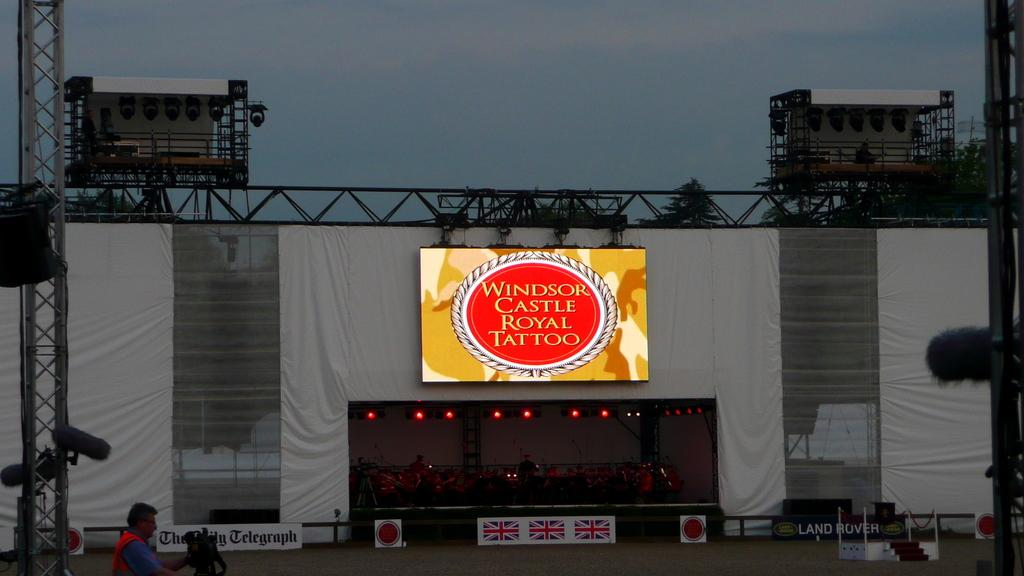<image>
Give a short and clear explanation of the subsequent image. A lit sign advertises Windsor Castle Royal Tattoo. 